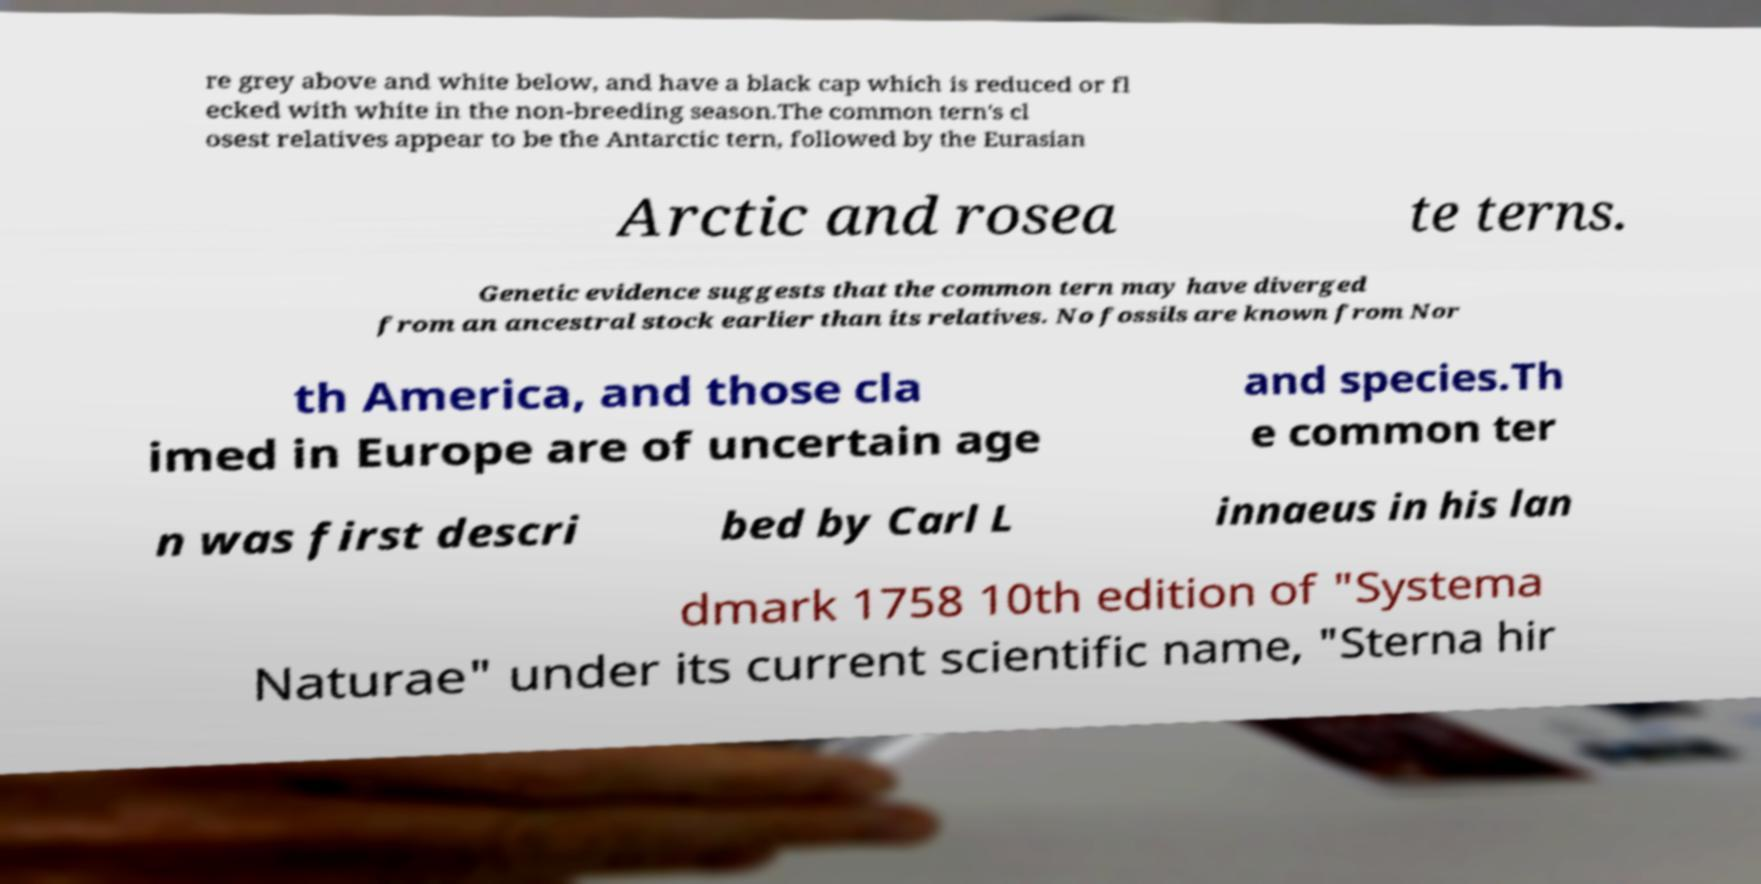What messages or text are displayed in this image? I need them in a readable, typed format. re grey above and white below, and have a black cap which is reduced or fl ecked with white in the non-breeding season.The common tern's cl osest relatives appear to be the Antarctic tern, followed by the Eurasian Arctic and rosea te terns. Genetic evidence suggests that the common tern may have diverged from an ancestral stock earlier than its relatives. No fossils are known from Nor th America, and those cla imed in Europe are of uncertain age and species.Th e common ter n was first descri bed by Carl L innaeus in his lan dmark 1758 10th edition of "Systema Naturae" under its current scientific name, "Sterna hir 